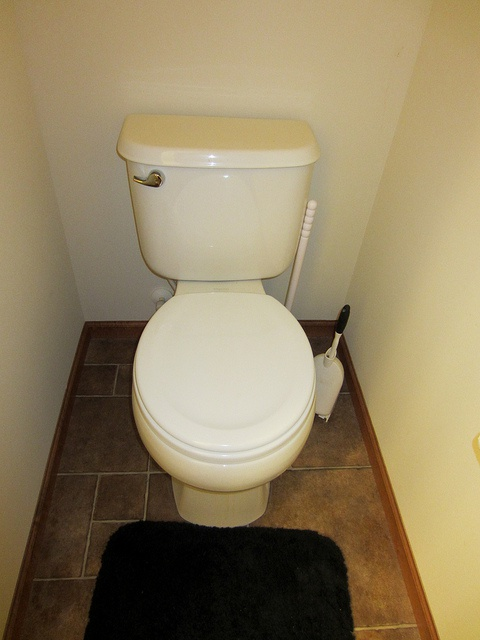Describe the objects in this image and their specific colors. I can see a toilet in olive, beige, lightgray, and tan tones in this image. 